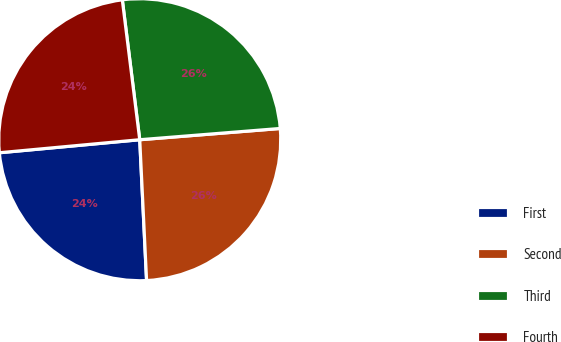Convert chart to OTSL. <chart><loc_0><loc_0><loc_500><loc_500><pie_chart><fcel>First<fcel>Second<fcel>Third<fcel>Fourth<nl><fcel>24.3%<fcel>25.5%<fcel>25.7%<fcel>24.5%<nl></chart> 